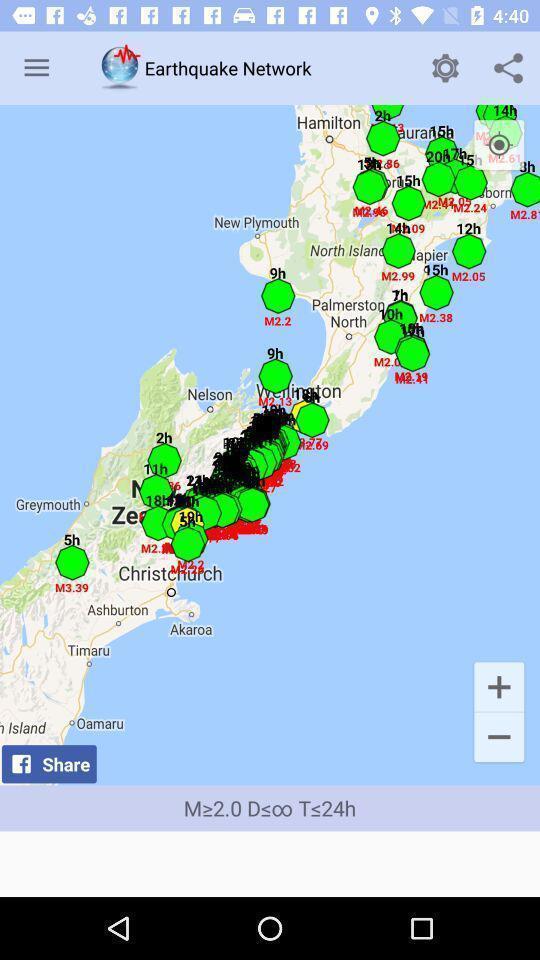Provide a textual representation of this image. Page showing information in comprehensive app. 